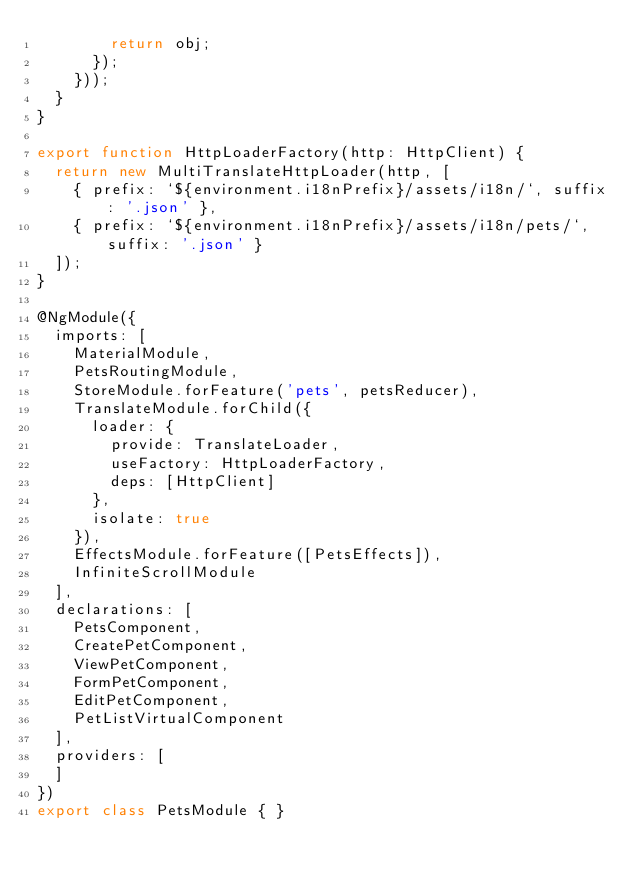Convert code to text. <code><loc_0><loc_0><loc_500><loc_500><_TypeScript_>        return obj;
      });
    }));
  }
}

export function HttpLoaderFactory(http: HttpClient) {
  return new MultiTranslateHttpLoader(http, [
    { prefix: `${environment.i18nPrefix}/assets/i18n/`, suffix: '.json' },
    { prefix: `${environment.i18nPrefix}/assets/i18n/pets/`, suffix: '.json' }
  ]);
}

@NgModule({
  imports: [
    MaterialModule,
    PetsRoutingModule,
    StoreModule.forFeature('pets', petsReducer),
    TranslateModule.forChild({
      loader: {
        provide: TranslateLoader,
        useFactory: HttpLoaderFactory,
        deps: [HttpClient]
      },
      isolate: true
    }),
    EffectsModule.forFeature([PetsEffects]),
    InfiniteScrollModule
  ],
  declarations: [
    PetsComponent,
    CreatePetComponent,
    ViewPetComponent,
    FormPetComponent,
    EditPetComponent,
    PetListVirtualComponent
  ],
  providers: [
  ]
})
export class PetsModule { }


</code> 